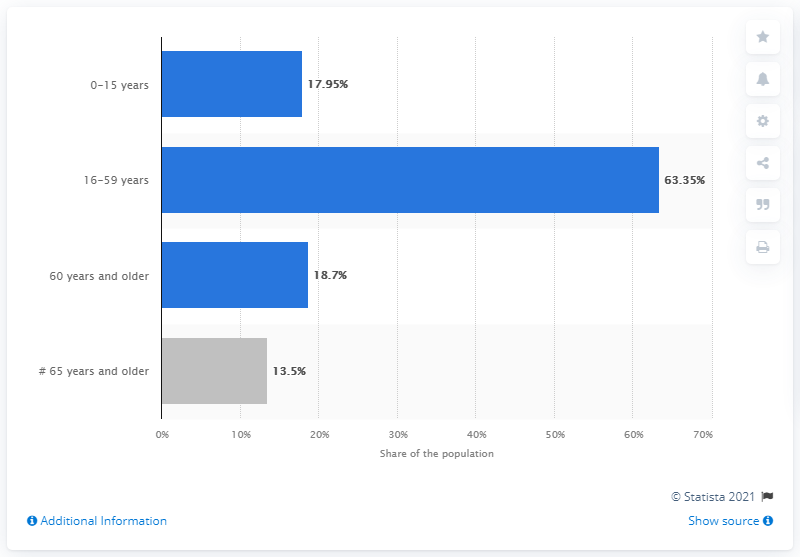Indicate a few pertinent items in this graphic. The Seventh Population Census conducted in China in 2020 revealed that 63.35% of the Chinese population was between 16 and 59 years old. 